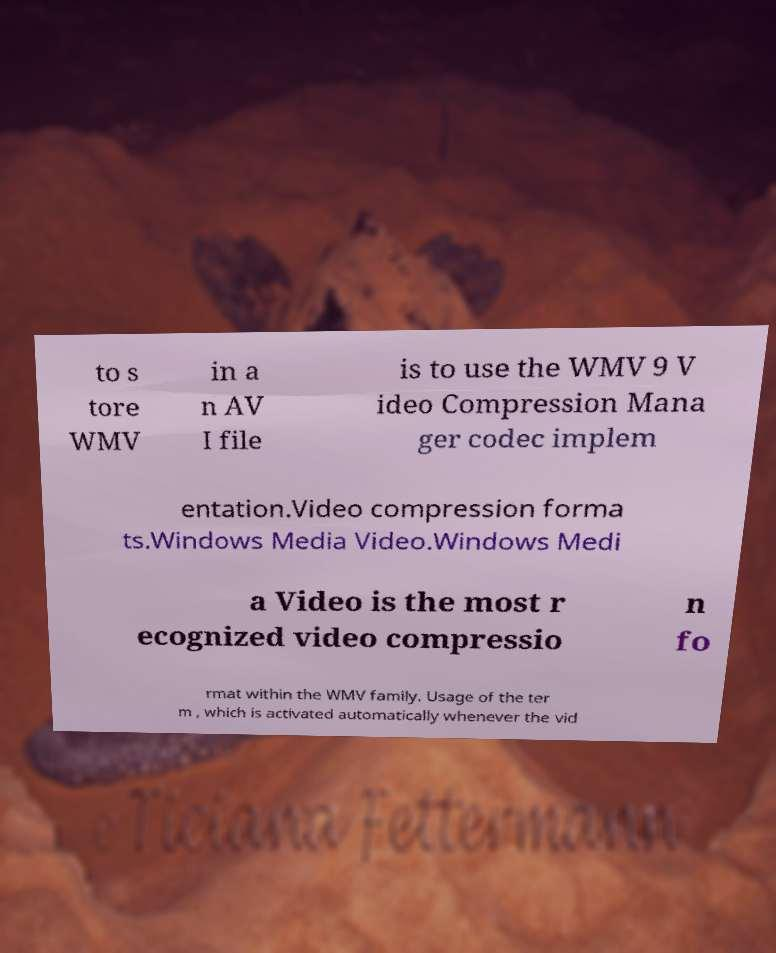Can you accurately transcribe the text from the provided image for me? to s tore WMV in a n AV I file is to use the WMV 9 V ideo Compression Mana ger codec implem entation.Video compression forma ts.Windows Media Video.Windows Medi a Video is the most r ecognized video compressio n fo rmat within the WMV family. Usage of the ter m , which is activated automatically whenever the vid 